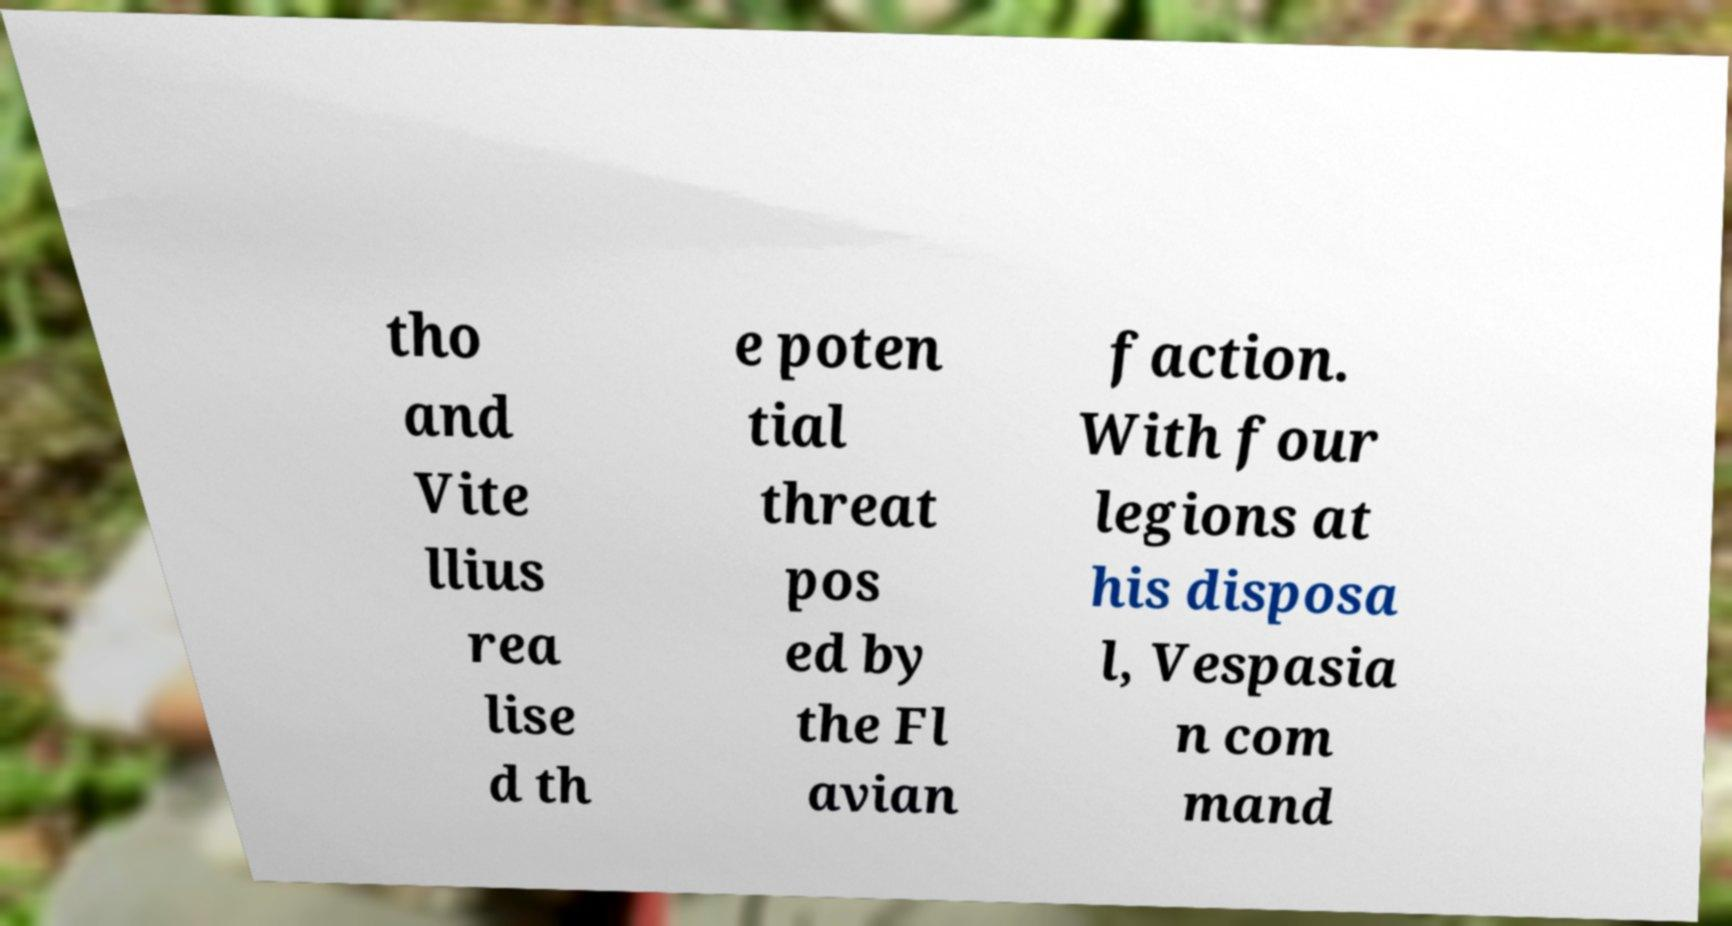Can you read and provide the text displayed in the image?This photo seems to have some interesting text. Can you extract and type it out for me? tho and Vite llius rea lise d th e poten tial threat pos ed by the Fl avian faction. With four legions at his disposa l, Vespasia n com mand 